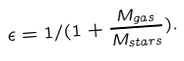Convert formula to latex. <formula><loc_0><loc_0><loc_500><loc_500>\epsilon = 1 / ( 1 + \frac { M _ { g a s } } { M _ { s t a r s } } ) .</formula> 